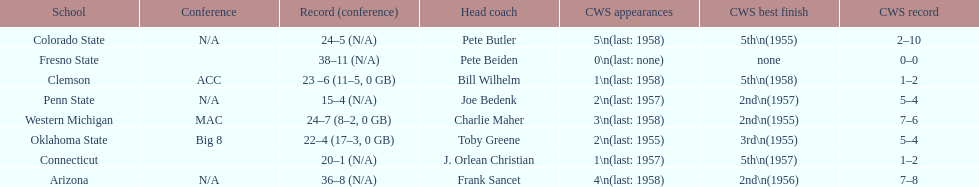Does clemson or western michigan have more cws appearances? Western Michigan. 